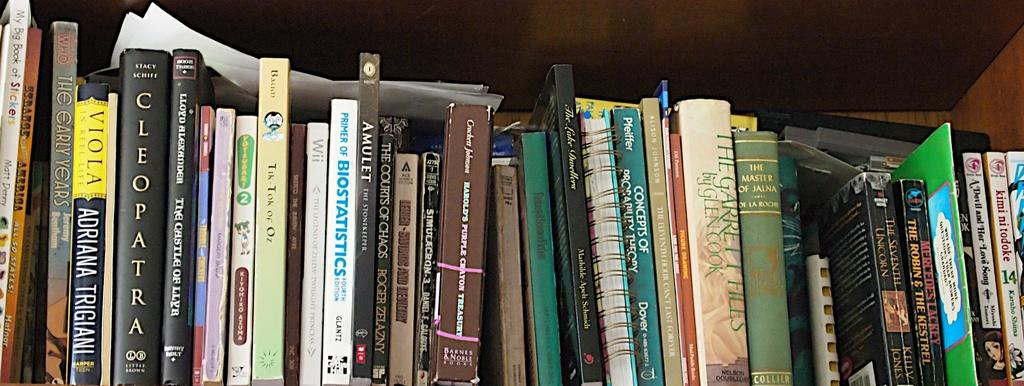<image>
Present a compact description of the photo's key features. A shelf full of books including Cleopatra and The Master of Jauna. 